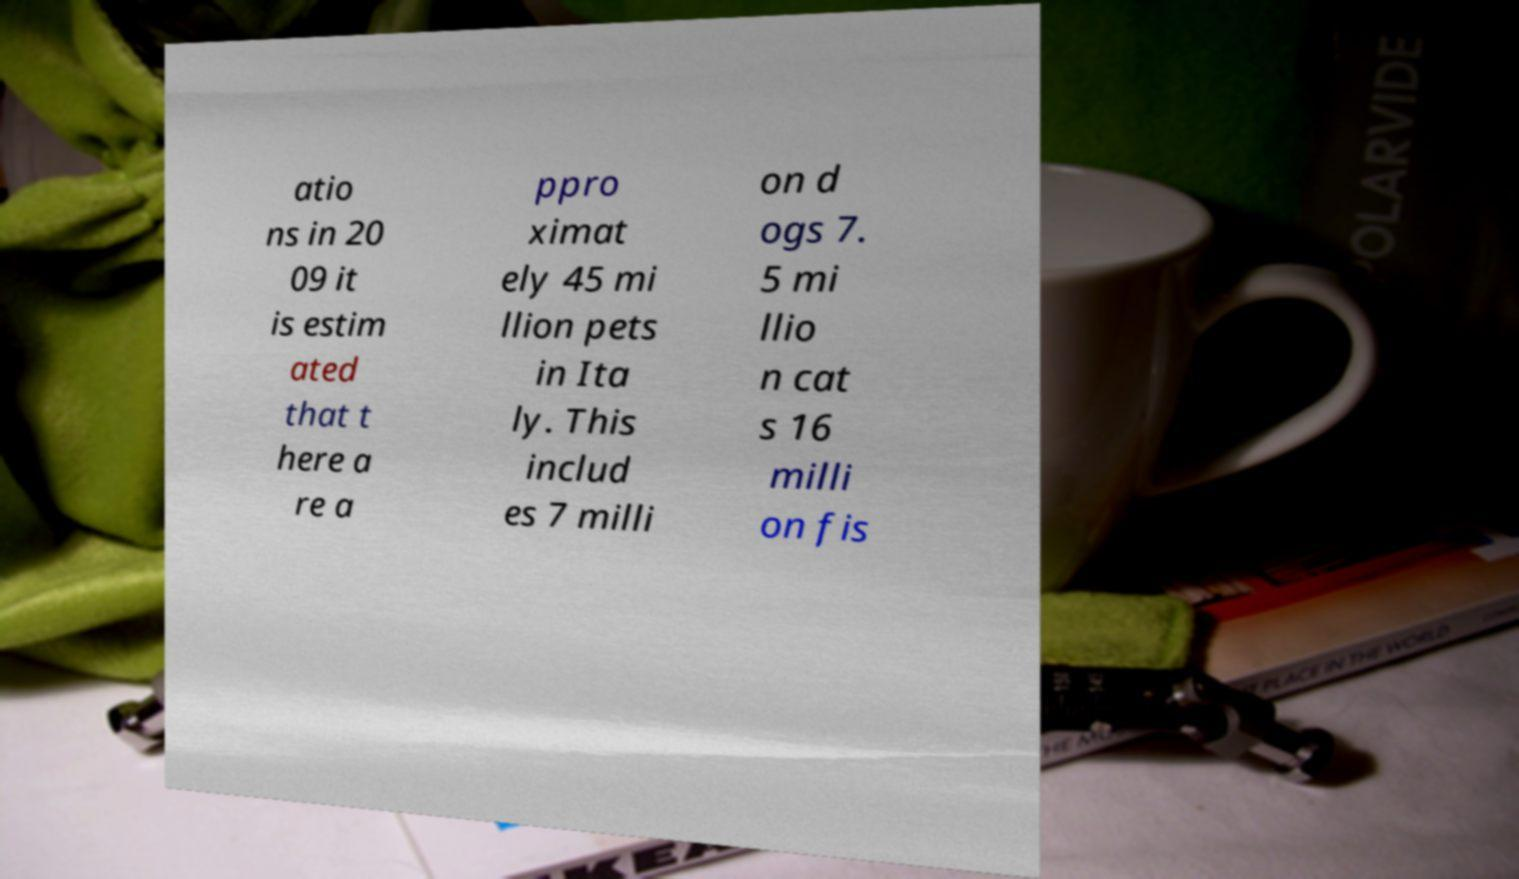Please read and relay the text visible in this image. What does it say? atio ns in 20 09 it is estim ated that t here a re a ppro ximat ely 45 mi llion pets in Ita ly. This includ es 7 milli on d ogs 7. 5 mi llio n cat s 16 milli on fis 